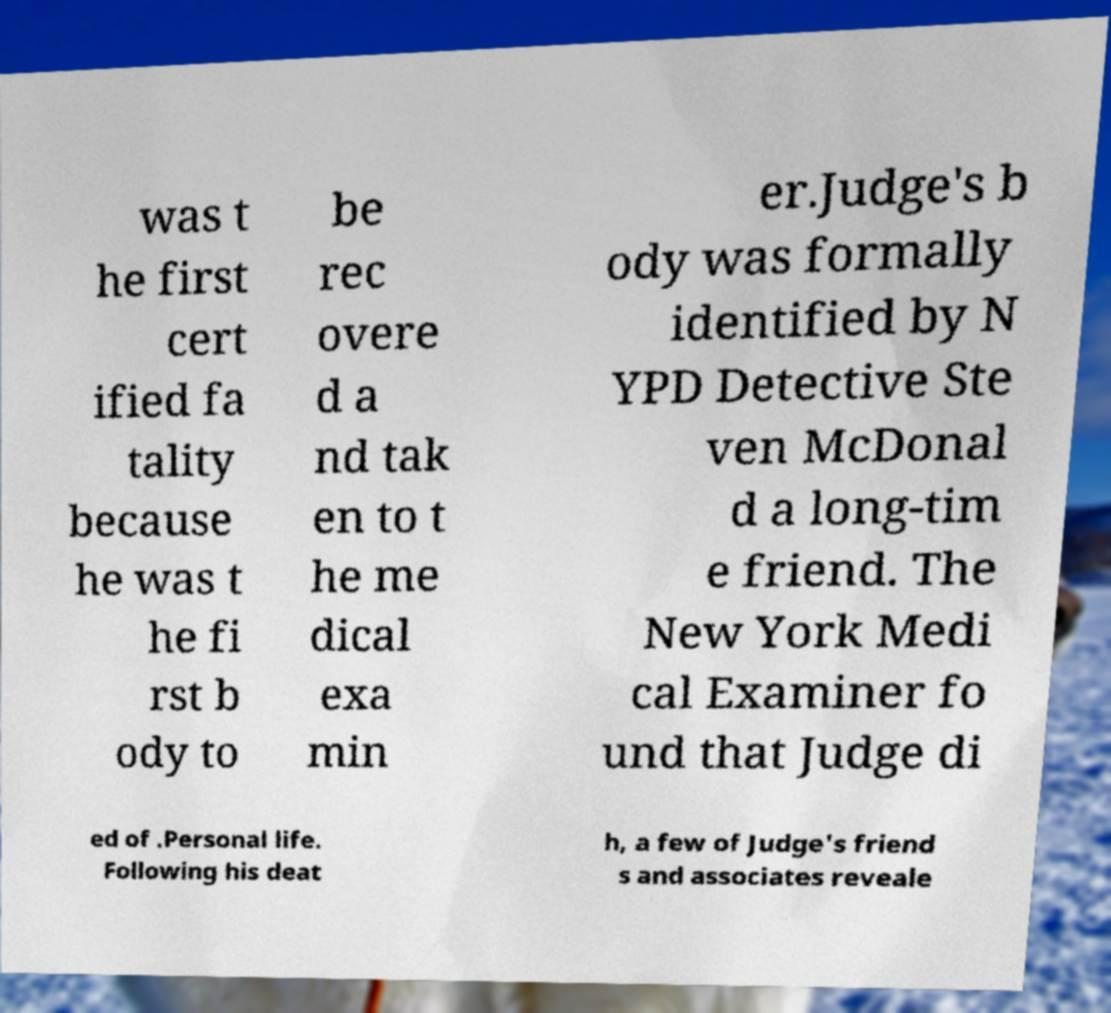Can you read and provide the text displayed in the image?This photo seems to have some interesting text. Can you extract and type it out for me? was t he first cert ified fa tality because he was t he fi rst b ody to be rec overe d a nd tak en to t he me dical exa min er.Judge's b ody was formally identified by N YPD Detective Ste ven McDonal d a long-tim e friend. The New York Medi cal Examiner fo und that Judge di ed of .Personal life. Following his deat h, a few of Judge's friend s and associates reveale 